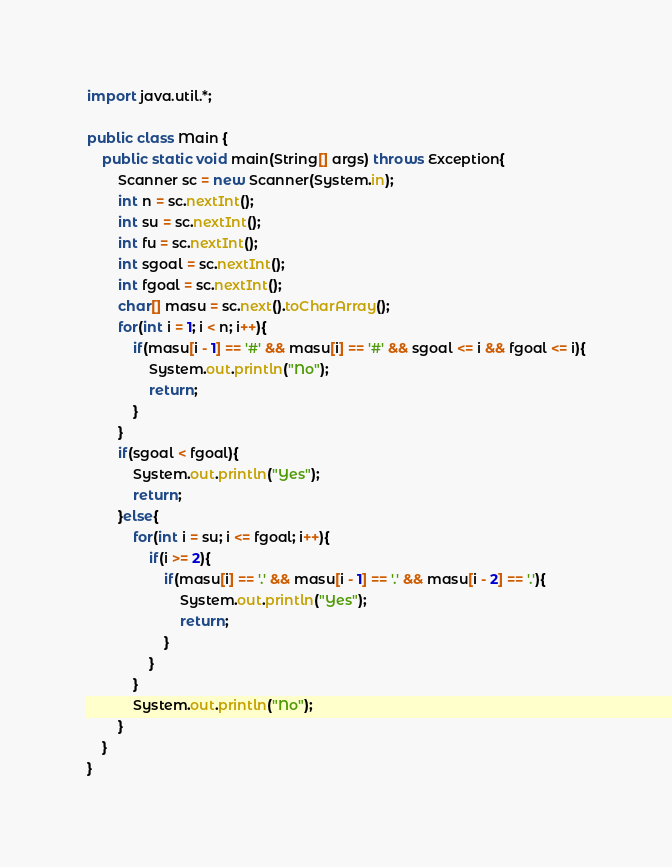Convert code to text. <code><loc_0><loc_0><loc_500><loc_500><_Java_>import java.util.*;
 
public class Main {
	public static void main(String[] args) throws Exception{
		Scanner sc = new Scanner(System.in);
        int n = sc.nextInt();
        int su = sc.nextInt();
        int fu = sc.nextInt();
        int sgoal = sc.nextInt();
        int fgoal = sc.nextInt();
        char[] masu = sc.next().toCharArray();
        for(int i = 1; i < n; i++){
        	if(masu[i - 1] == '#' && masu[i] == '#' && sgoal <= i && fgoal <= i){
            	System.out.println("No");
                return;
            }
        }
        if(sgoal < fgoal){
        	System.out.println("Yes");
            return;
        }else{
        	for(int i = su; i <= fgoal; i++){
            	if(i >= 2){
                	if(masu[i] == '.' && masu[i - 1] == '.' && masu[i - 2] == '.'){
                    	System.out.println("Yes");
                        return;
                    }
                }
            }
            System.out.println("No");
        }
	}
}</code> 